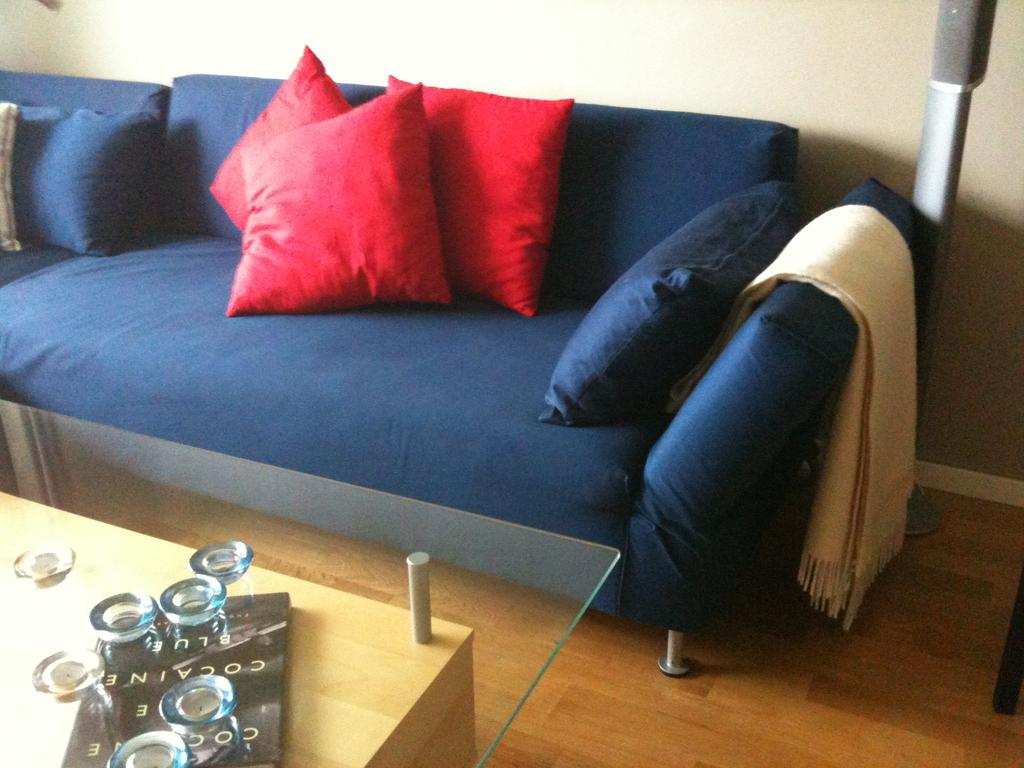What is the main subject of the image? The main subject of the image is a man. What is the man doing in the image? The man is standing in the image. What object is the man holding in his hand? The man is holding a guitar in his hand. What type of tent can be seen in the background of the image? There is no tent present in the image; it features a man standing and holding a guitar. What kind of fuel is being used by the man in the image? There is no fuel mentioned or depicted in the image, as it only shows a man standing and holding a guitar. 